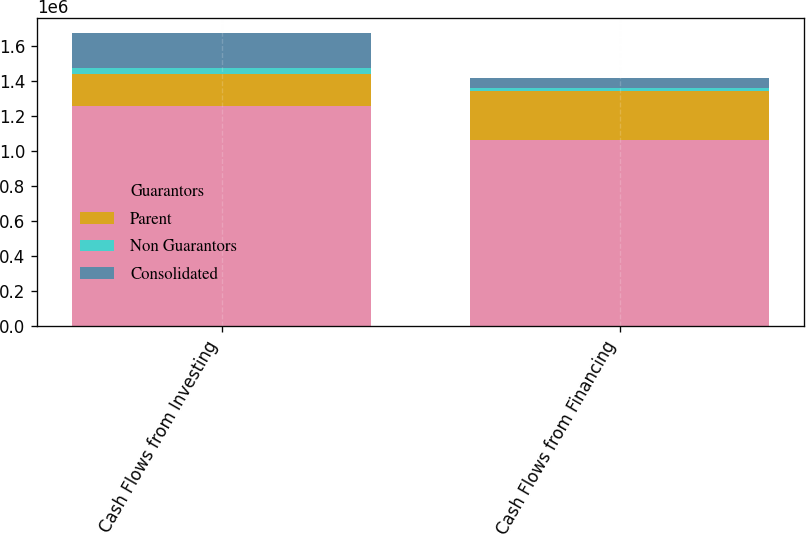<chart> <loc_0><loc_0><loc_500><loc_500><stacked_bar_chart><ecel><fcel>Cash Flows from Investing<fcel>Cash Flows from Financing<nl><fcel>Guarantors<fcel>1.25893e+06<fcel>1.06572e+06<nl><fcel>Parent<fcel>180800<fcel>277430<nl><fcel>Non Guarantors<fcel>36162<fcel>15803<nl><fcel>Consolidated<fcel>198374<fcel>55234<nl></chart> 